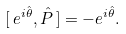<formula> <loc_0><loc_0><loc_500><loc_500>[ \, e ^ { i \hat { \theta } } , \hat { P } \, ] = - e ^ { i \hat { \theta } } .</formula> 